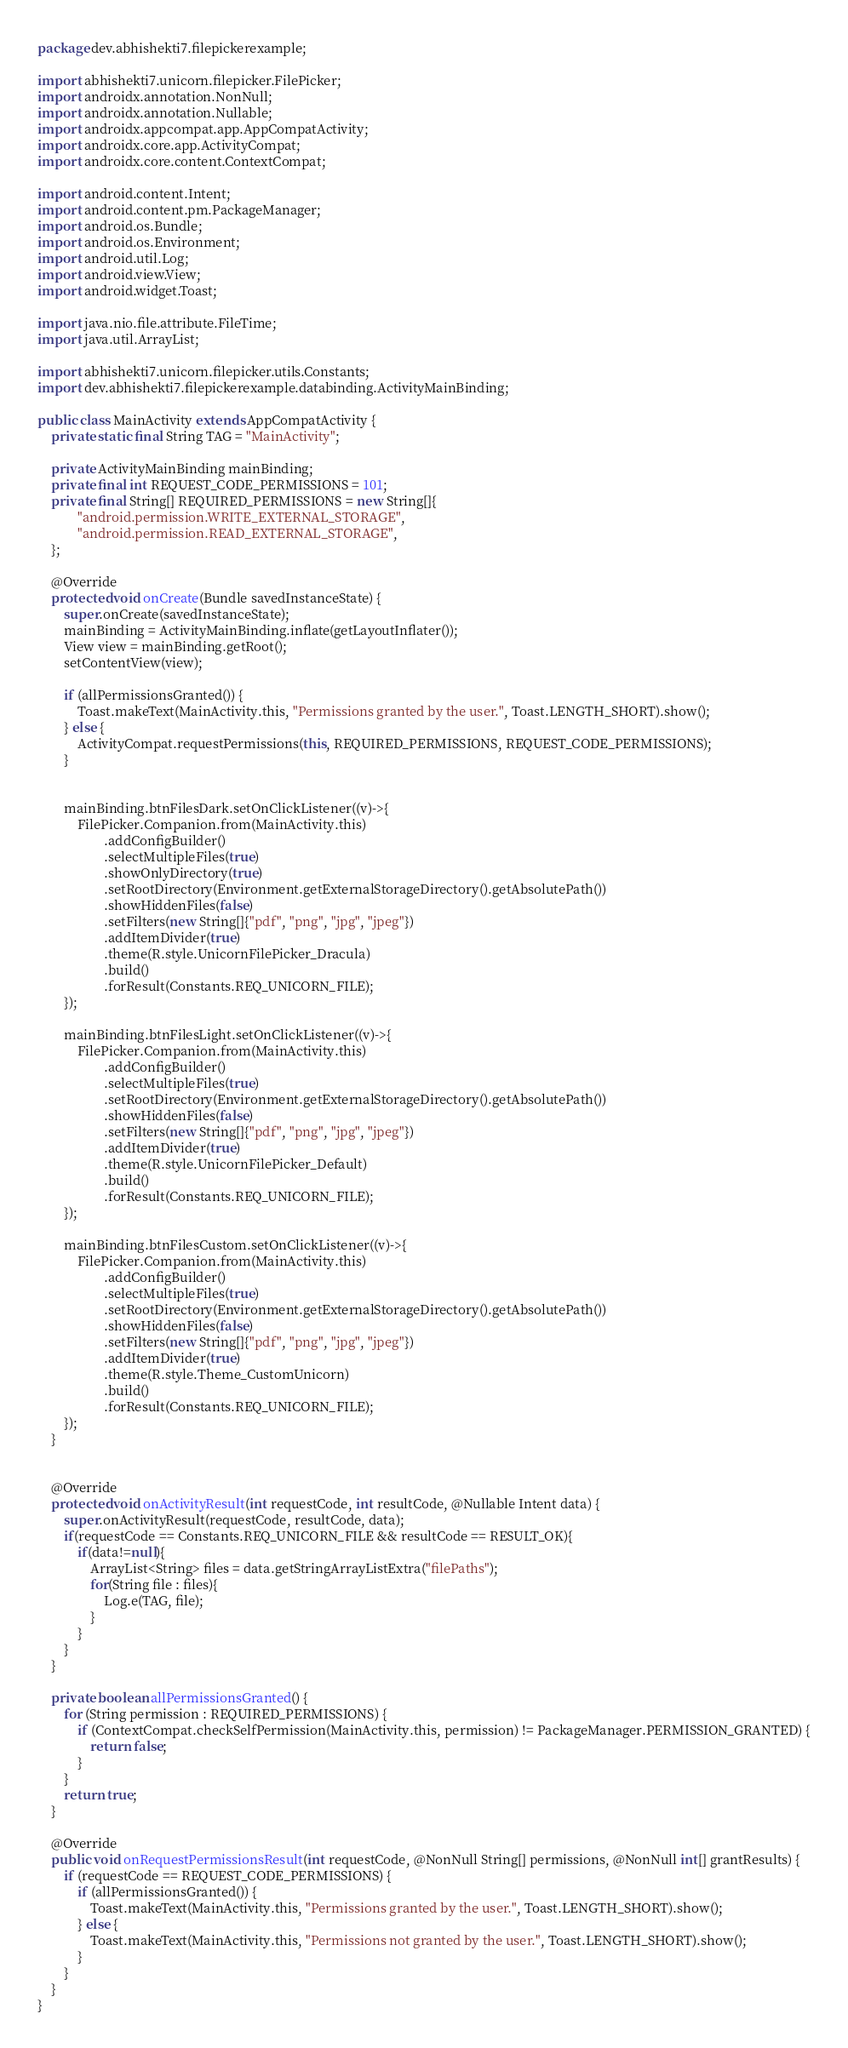Convert code to text. <code><loc_0><loc_0><loc_500><loc_500><_Java_>package dev.abhishekti7.filepickerexample;

import abhishekti7.unicorn.filepicker.FilePicker;
import androidx.annotation.NonNull;
import androidx.annotation.Nullable;
import androidx.appcompat.app.AppCompatActivity;
import androidx.core.app.ActivityCompat;
import androidx.core.content.ContextCompat;

import android.content.Intent;
import android.content.pm.PackageManager;
import android.os.Bundle;
import android.os.Environment;
import android.util.Log;
import android.view.View;
import android.widget.Toast;

import java.nio.file.attribute.FileTime;
import java.util.ArrayList;

import abhishekti7.unicorn.filepicker.utils.Constants;
import dev.abhishekti7.filepickerexample.databinding.ActivityMainBinding;

public class MainActivity extends AppCompatActivity {
    private static final String TAG = "MainActivity";

    private ActivityMainBinding mainBinding;
    private final int REQUEST_CODE_PERMISSIONS = 101;
    private final String[] REQUIRED_PERMISSIONS = new String[]{
            "android.permission.WRITE_EXTERNAL_STORAGE",
            "android.permission.READ_EXTERNAL_STORAGE",
    };

    @Override
    protected void onCreate(Bundle savedInstanceState) {
        super.onCreate(savedInstanceState);
        mainBinding = ActivityMainBinding.inflate(getLayoutInflater());
        View view = mainBinding.getRoot();
        setContentView(view);

        if (allPermissionsGranted()) {
            Toast.makeText(MainActivity.this, "Permissions granted by the user.", Toast.LENGTH_SHORT).show();
        } else {
            ActivityCompat.requestPermissions(this, REQUIRED_PERMISSIONS, REQUEST_CODE_PERMISSIONS);
        }


        mainBinding.btnFilesDark.setOnClickListener((v)->{
            FilePicker.Companion.from(MainActivity.this)
                    .addConfigBuilder()
                    .selectMultipleFiles(true)
                    .showOnlyDirectory(true)
                    .setRootDirectory(Environment.getExternalStorageDirectory().getAbsolutePath())
                    .showHiddenFiles(false)
                    .setFilters(new String[]{"pdf", "png", "jpg", "jpeg"})
                    .addItemDivider(true)
                    .theme(R.style.UnicornFilePicker_Dracula)
                    .build()
                    .forResult(Constants.REQ_UNICORN_FILE);
        });

        mainBinding.btnFilesLight.setOnClickListener((v)->{
            FilePicker.Companion.from(MainActivity.this)
                    .addConfigBuilder()
                    .selectMultipleFiles(true)
                    .setRootDirectory(Environment.getExternalStorageDirectory().getAbsolutePath())
                    .showHiddenFiles(false)
                    .setFilters(new String[]{"pdf", "png", "jpg", "jpeg"})
                    .addItemDivider(true)
                    .theme(R.style.UnicornFilePicker_Default)
                    .build()
                    .forResult(Constants.REQ_UNICORN_FILE);
        });

        mainBinding.btnFilesCustom.setOnClickListener((v)->{
            FilePicker.Companion.from(MainActivity.this)
                    .addConfigBuilder()
                    .selectMultipleFiles(true)
                    .setRootDirectory(Environment.getExternalStorageDirectory().getAbsolutePath())
                    .showHiddenFiles(false)
                    .setFilters(new String[]{"pdf", "png", "jpg", "jpeg"})
                    .addItemDivider(true)
                    .theme(R.style.Theme_CustomUnicorn)
                    .build()
                    .forResult(Constants.REQ_UNICORN_FILE);
        });
    }


    @Override
    protected void onActivityResult(int requestCode, int resultCode, @Nullable Intent data) {
        super.onActivityResult(requestCode, resultCode, data);
        if(requestCode == Constants.REQ_UNICORN_FILE && resultCode == RESULT_OK){
            if(data!=null){
                ArrayList<String> files = data.getStringArrayListExtra("filePaths");
                for(String file : files){
                    Log.e(TAG, file);
                }
            }
        }
    }

    private boolean allPermissionsGranted() {
        for (String permission : REQUIRED_PERMISSIONS) {
            if (ContextCompat.checkSelfPermission(MainActivity.this, permission) != PackageManager.PERMISSION_GRANTED) {
                return false;
            }
        }
        return true;
    }

    @Override
    public void onRequestPermissionsResult(int requestCode, @NonNull String[] permissions, @NonNull int[] grantResults) {
        if (requestCode == REQUEST_CODE_PERMISSIONS) {
            if (allPermissionsGranted()) {
                Toast.makeText(MainActivity.this, "Permissions granted by the user.", Toast.LENGTH_SHORT).show();
            } else {
                Toast.makeText(MainActivity.this, "Permissions not granted by the user.", Toast.LENGTH_SHORT).show();
            }
        }
    }
}
</code> 